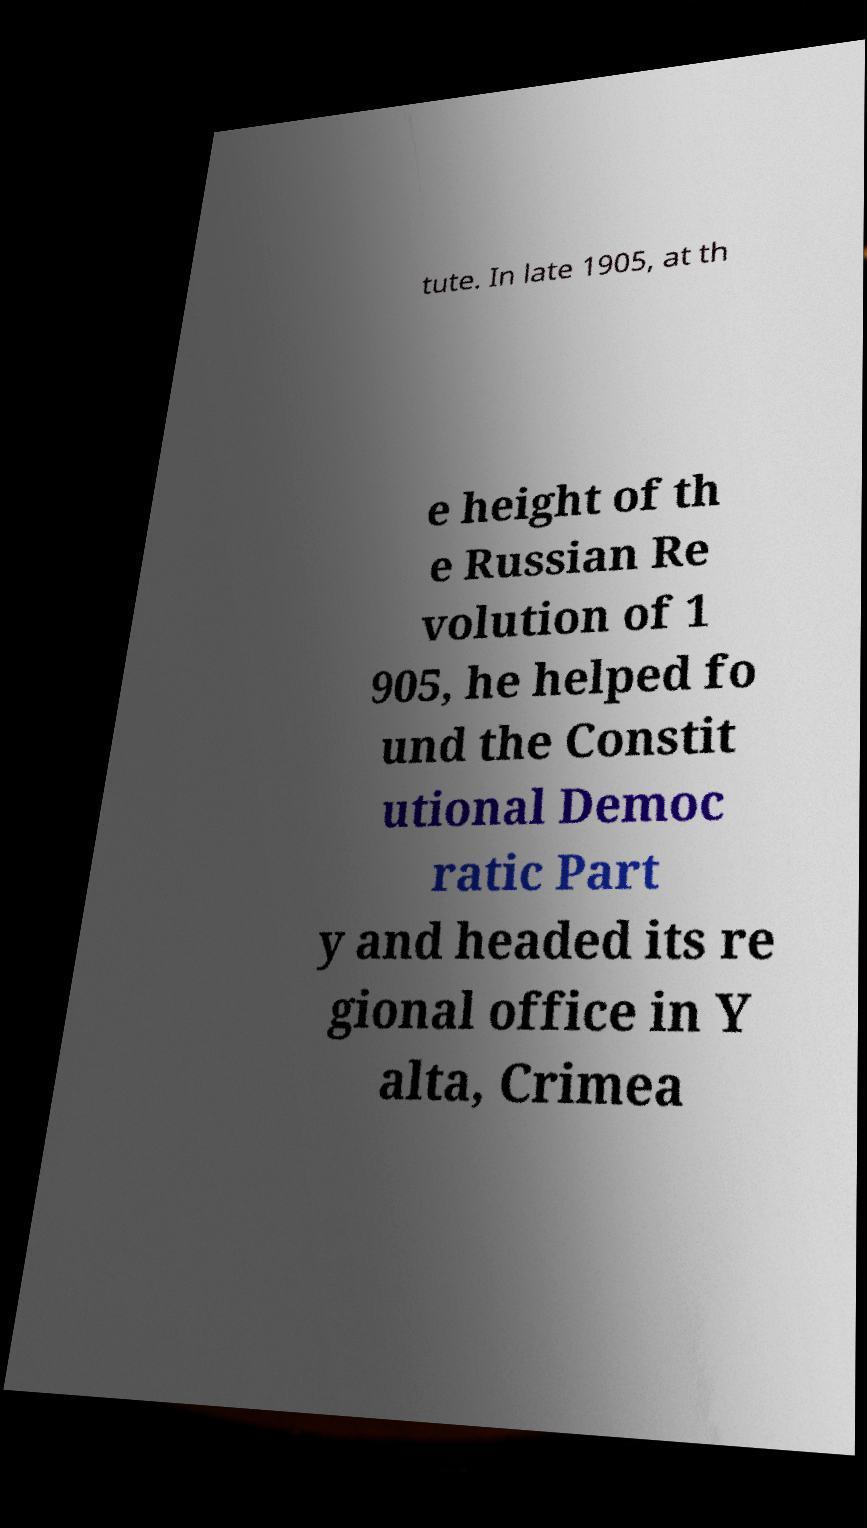Please read and relay the text visible in this image. What does it say? tute. In late 1905, at th e height of th e Russian Re volution of 1 905, he helped fo und the Constit utional Democ ratic Part y and headed its re gional office in Y alta, Crimea 